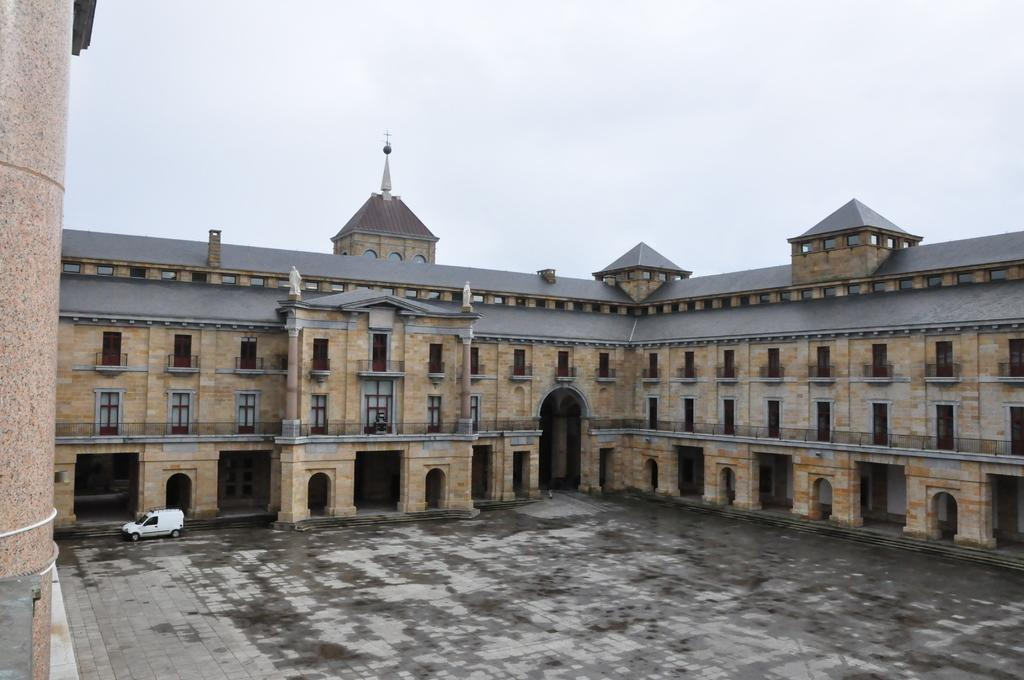What type of structure is present in the image? There is a building in the image. What other objects can be seen in the image? There are statues and a motor vehicle on the floor in the image. What is visible in the background of the image? The sky is visible in the background of the image. What type of crack can be heard in the image? There is no sound, such as a crack, present in the image. What type of prose is being recited in the image? There is no prose or any form of literature being recited in the image. 